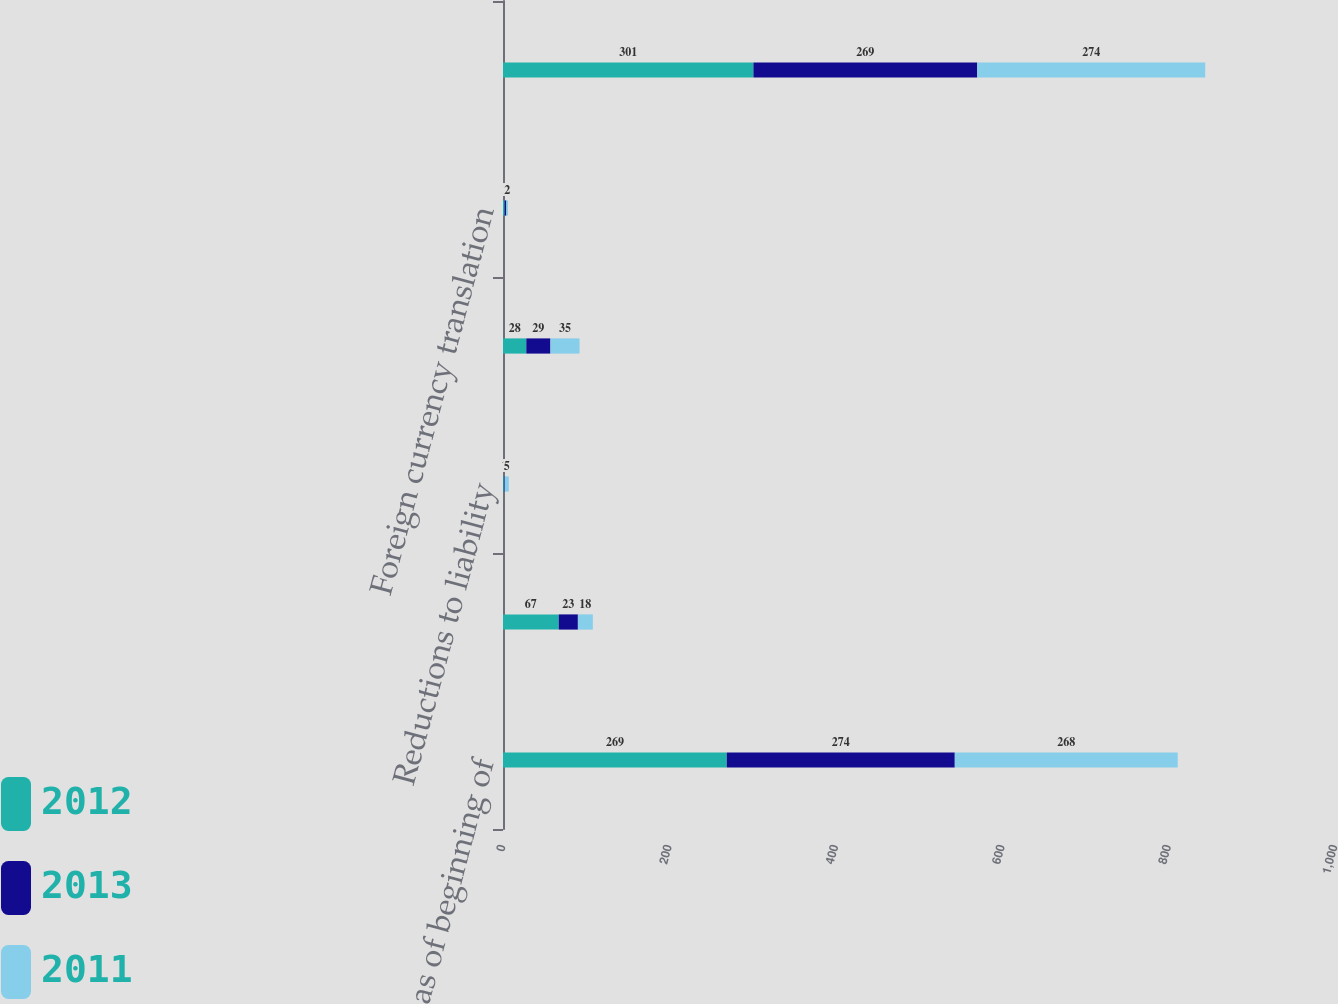<chart> <loc_0><loc_0><loc_500><loc_500><stacked_bar_chart><ecel><fcel>Balance as of beginning of<fcel>Additions to liability<fcel>Reductions to liability<fcel>Payments net of third-party<fcel>Foreign currency translation<fcel>Balance as of end of year<nl><fcel>2012<fcel>269<fcel>67<fcel>1<fcel>28<fcel>2<fcel>301<nl><fcel>2013<fcel>274<fcel>23<fcel>1<fcel>29<fcel>2<fcel>269<nl><fcel>2011<fcel>268<fcel>18<fcel>5<fcel>35<fcel>2<fcel>274<nl></chart> 